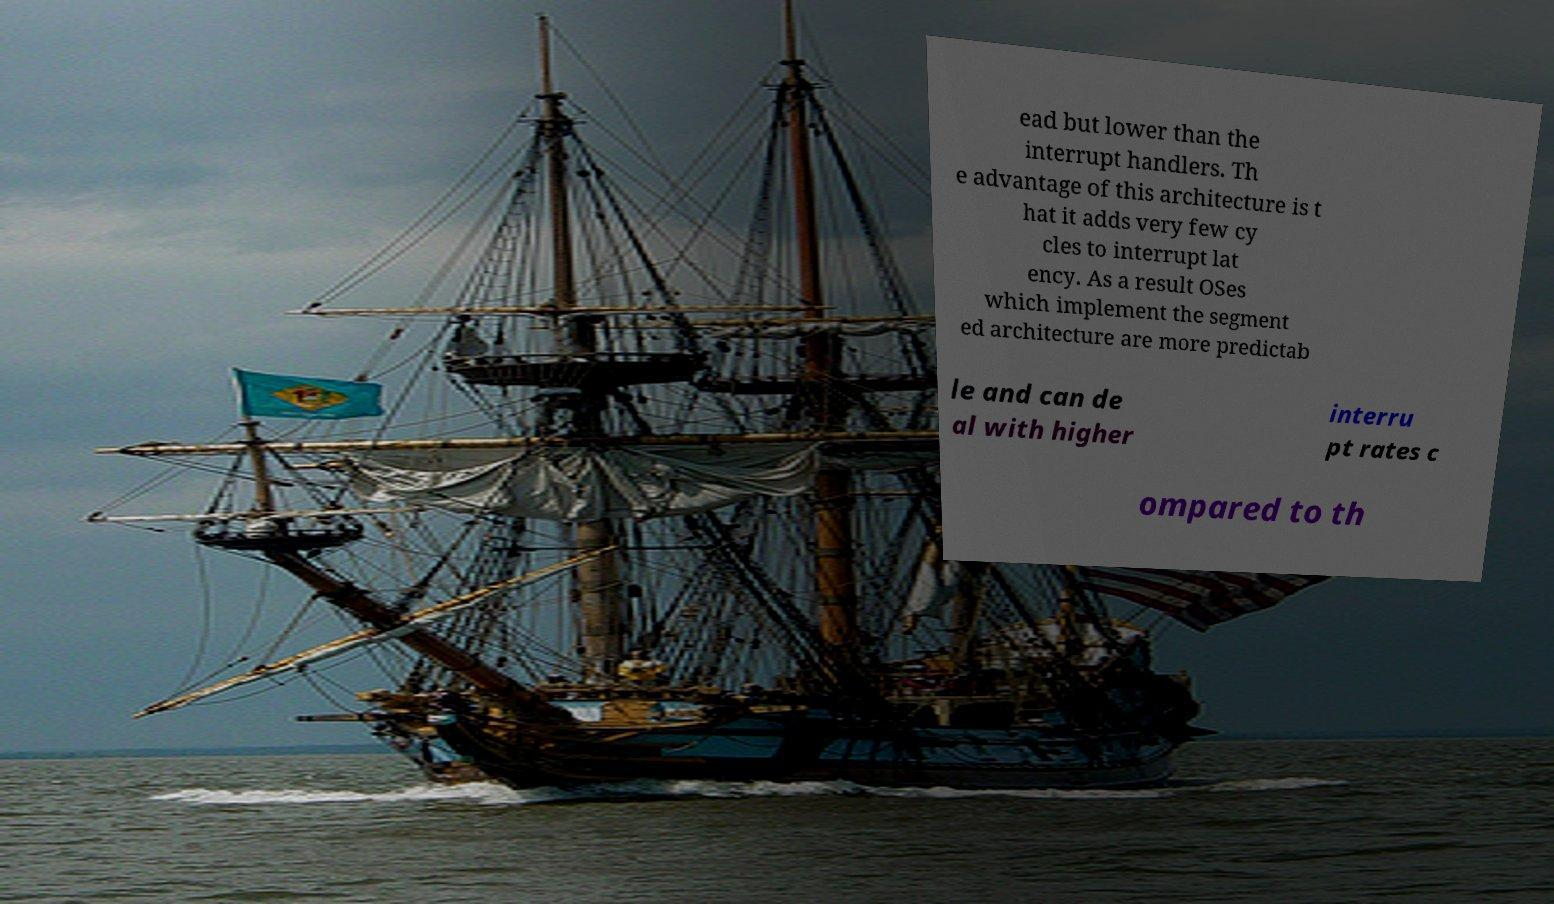Can you accurately transcribe the text from the provided image for me? ead but lower than the interrupt handlers. Th e advantage of this architecture is t hat it adds very few cy cles to interrupt lat ency. As a result OSes which implement the segment ed architecture are more predictab le and can de al with higher interru pt rates c ompared to th 